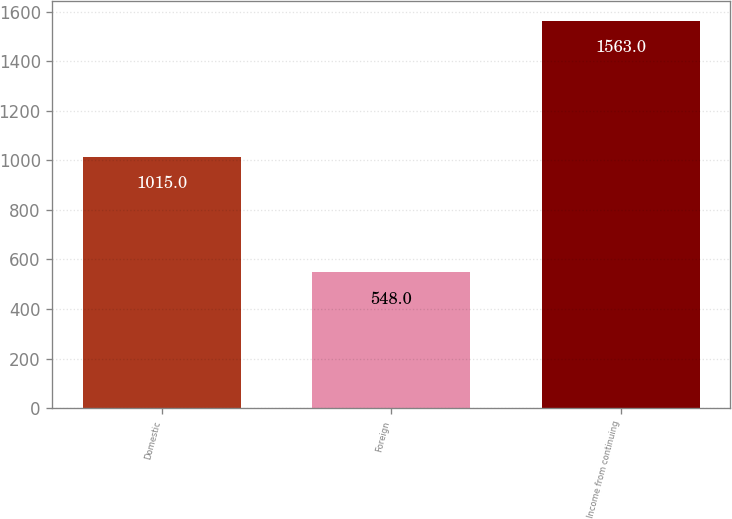<chart> <loc_0><loc_0><loc_500><loc_500><bar_chart><fcel>Domestic<fcel>Foreign<fcel>Income from continuing<nl><fcel>1015<fcel>548<fcel>1563<nl></chart> 